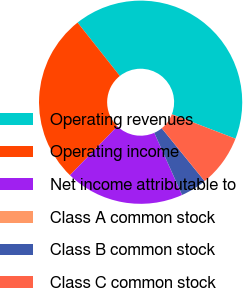Convert chart. <chart><loc_0><loc_0><loc_500><loc_500><pie_chart><fcel>Operating revenues<fcel>Operating income<fcel>Net income attributable to<fcel>Class A common stock<fcel>Class B common stock<fcel>Class C common stock<nl><fcel>41.5%<fcel>27.1%<fcel>18.92%<fcel>0.01%<fcel>4.16%<fcel>8.31%<nl></chart> 